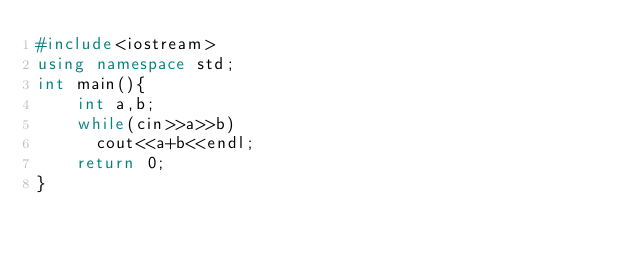Convert code to text. <code><loc_0><loc_0><loc_500><loc_500><_C++_>#include<iostream>
using namespace std;
int main(){
    int a,b;
    while(cin>>a>>b)
      cout<<a+b<<endl;
    return 0;
}</code> 